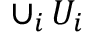Convert formula to latex. <formula><loc_0><loc_0><loc_500><loc_500>\cup _ { i } \, U _ { i }</formula> 